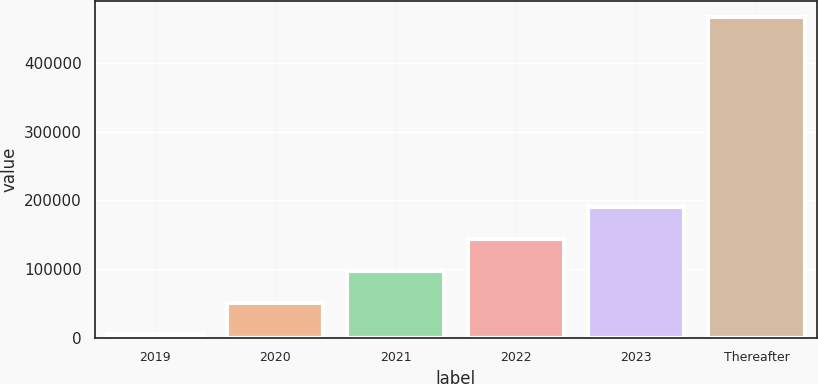<chart> <loc_0><loc_0><loc_500><loc_500><bar_chart><fcel>2019<fcel>2020<fcel>2021<fcel>2022<fcel>2023<fcel>Thereafter<nl><fcel>5597<fcel>51650.3<fcel>97703.6<fcel>143757<fcel>189810<fcel>466130<nl></chart> 